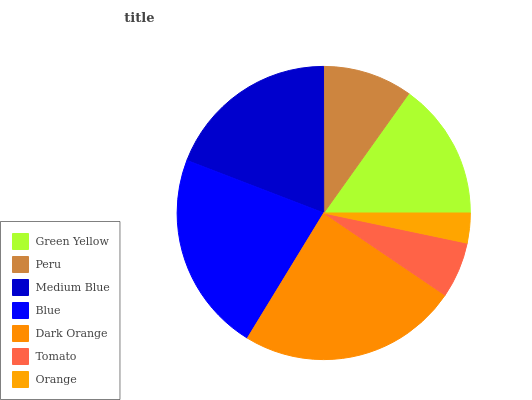Is Orange the minimum?
Answer yes or no. Yes. Is Dark Orange the maximum?
Answer yes or no. Yes. Is Peru the minimum?
Answer yes or no. No. Is Peru the maximum?
Answer yes or no. No. Is Green Yellow greater than Peru?
Answer yes or no. Yes. Is Peru less than Green Yellow?
Answer yes or no. Yes. Is Peru greater than Green Yellow?
Answer yes or no. No. Is Green Yellow less than Peru?
Answer yes or no. No. Is Green Yellow the high median?
Answer yes or no. Yes. Is Green Yellow the low median?
Answer yes or no. Yes. Is Peru the high median?
Answer yes or no. No. Is Medium Blue the low median?
Answer yes or no. No. 